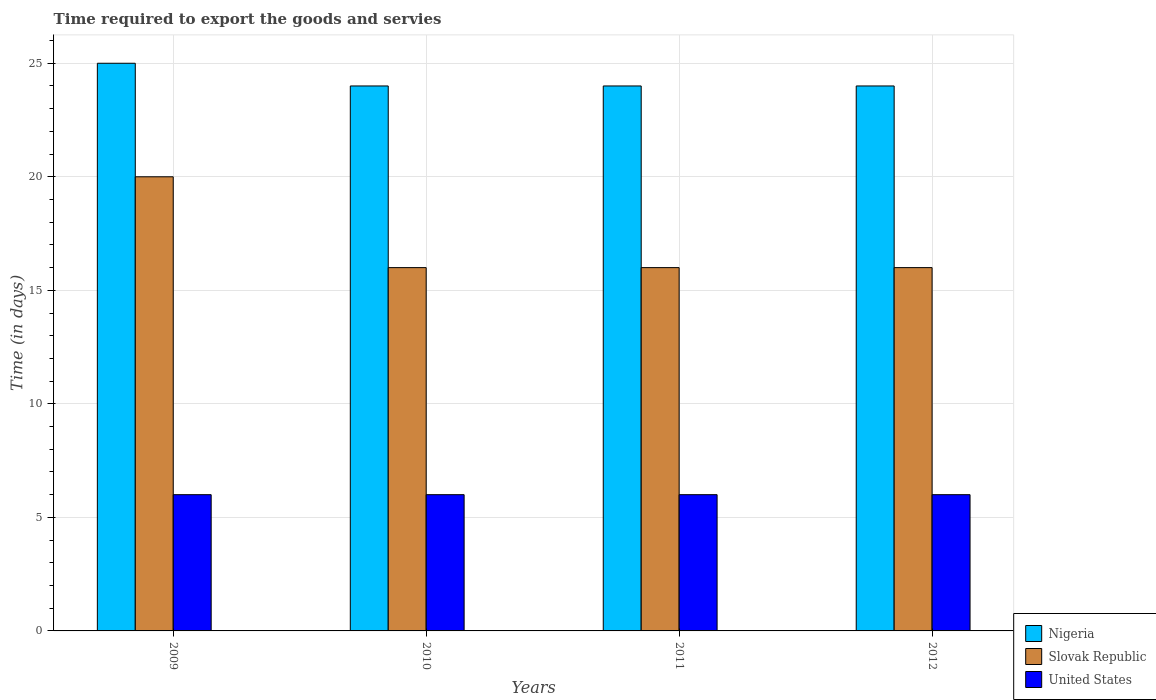How many groups of bars are there?
Your answer should be compact. 4. Are the number of bars per tick equal to the number of legend labels?
Offer a very short reply. Yes. Are the number of bars on each tick of the X-axis equal?
Keep it short and to the point. Yes. How many bars are there on the 2nd tick from the right?
Give a very brief answer. 3. What is the number of days required to export the goods and services in Slovak Republic in 2012?
Provide a short and direct response. 16. Across all years, what is the maximum number of days required to export the goods and services in Slovak Republic?
Your answer should be very brief. 20. Across all years, what is the minimum number of days required to export the goods and services in United States?
Provide a succinct answer. 6. In which year was the number of days required to export the goods and services in United States maximum?
Offer a terse response. 2009. In which year was the number of days required to export the goods and services in Nigeria minimum?
Provide a succinct answer. 2010. What is the total number of days required to export the goods and services in United States in the graph?
Your answer should be very brief. 24. What is the difference between the number of days required to export the goods and services in United States in 2009 and that in 2011?
Make the answer very short. 0. What is the difference between the number of days required to export the goods and services in Slovak Republic in 2011 and the number of days required to export the goods and services in United States in 2009?
Your answer should be very brief. 10. In the year 2010, what is the difference between the number of days required to export the goods and services in United States and number of days required to export the goods and services in Nigeria?
Give a very brief answer. -18. In how many years, is the number of days required to export the goods and services in United States greater than 12 days?
Ensure brevity in your answer.  0. What is the ratio of the number of days required to export the goods and services in United States in 2009 to that in 2010?
Offer a very short reply. 1. What is the difference between the highest and the lowest number of days required to export the goods and services in Slovak Republic?
Give a very brief answer. 4. In how many years, is the number of days required to export the goods and services in Slovak Republic greater than the average number of days required to export the goods and services in Slovak Republic taken over all years?
Your response must be concise. 1. Is the sum of the number of days required to export the goods and services in Nigeria in 2009 and 2012 greater than the maximum number of days required to export the goods and services in United States across all years?
Offer a terse response. Yes. What does the 1st bar from the left in 2009 represents?
Give a very brief answer. Nigeria. What does the 2nd bar from the right in 2011 represents?
Offer a very short reply. Slovak Republic. Is it the case that in every year, the sum of the number of days required to export the goods and services in Nigeria and number of days required to export the goods and services in Slovak Republic is greater than the number of days required to export the goods and services in United States?
Make the answer very short. Yes. Are all the bars in the graph horizontal?
Your answer should be very brief. No. What is the difference between two consecutive major ticks on the Y-axis?
Provide a short and direct response. 5. Are the values on the major ticks of Y-axis written in scientific E-notation?
Keep it short and to the point. No. Where does the legend appear in the graph?
Your answer should be compact. Bottom right. How are the legend labels stacked?
Give a very brief answer. Vertical. What is the title of the graph?
Offer a terse response. Time required to export the goods and servies. Does "Germany" appear as one of the legend labels in the graph?
Ensure brevity in your answer.  No. What is the label or title of the X-axis?
Provide a succinct answer. Years. What is the label or title of the Y-axis?
Your answer should be compact. Time (in days). What is the Time (in days) of Slovak Republic in 2009?
Offer a terse response. 20. What is the Time (in days) of United States in 2009?
Keep it short and to the point. 6. What is the Time (in days) in Nigeria in 2010?
Make the answer very short. 24. What is the Time (in days) in Nigeria in 2012?
Ensure brevity in your answer.  24. What is the Time (in days) in United States in 2012?
Your answer should be compact. 6. Across all years, what is the maximum Time (in days) in Nigeria?
Offer a very short reply. 25. Across all years, what is the maximum Time (in days) in United States?
Offer a very short reply. 6. Across all years, what is the minimum Time (in days) of Nigeria?
Make the answer very short. 24. Across all years, what is the minimum Time (in days) of Slovak Republic?
Offer a very short reply. 16. Across all years, what is the minimum Time (in days) of United States?
Your answer should be very brief. 6. What is the total Time (in days) of Nigeria in the graph?
Provide a short and direct response. 97. What is the difference between the Time (in days) of Nigeria in 2009 and that in 2010?
Offer a terse response. 1. What is the difference between the Time (in days) in Slovak Republic in 2009 and that in 2010?
Your answer should be compact. 4. What is the difference between the Time (in days) of Nigeria in 2009 and that in 2011?
Your answer should be compact. 1. What is the difference between the Time (in days) of Slovak Republic in 2009 and that in 2011?
Give a very brief answer. 4. What is the difference between the Time (in days) of United States in 2009 and that in 2011?
Keep it short and to the point. 0. What is the difference between the Time (in days) of United States in 2009 and that in 2012?
Keep it short and to the point. 0. What is the difference between the Time (in days) of Nigeria in 2010 and that in 2011?
Offer a terse response. 0. What is the difference between the Time (in days) of Slovak Republic in 2010 and that in 2011?
Make the answer very short. 0. What is the difference between the Time (in days) in Nigeria in 2010 and that in 2012?
Your answer should be very brief. 0. What is the difference between the Time (in days) in Slovak Republic in 2010 and that in 2012?
Offer a very short reply. 0. What is the difference between the Time (in days) in United States in 2010 and that in 2012?
Your response must be concise. 0. What is the difference between the Time (in days) in Nigeria in 2011 and that in 2012?
Your response must be concise. 0. What is the difference between the Time (in days) in Slovak Republic in 2011 and that in 2012?
Your response must be concise. 0. What is the difference between the Time (in days) in United States in 2011 and that in 2012?
Provide a succinct answer. 0. What is the difference between the Time (in days) of Nigeria in 2009 and the Time (in days) of Slovak Republic in 2011?
Offer a terse response. 9. What is the difference between the Time (in days) in Nigeria in 2009 and the Time (in days) in United States in 2011?
Offer a terse response. 19. What is the difference between the Time (in days) of Nigeria in 2009 and the Time (in days) of Slovak Republic in 2012?
Your answer should be compact. 9. What is the difference between the Time (in days) in Nigeria in 2010 and the Time (in days) in United States in 2011?
Provide a succinct answer. 18. What is the difference between the Time (in days) in Slovak Republic in 2010 and the Time (in days) in United States in 2011?
Your response must be concise. 10. What is the difference between the Time (in days) of Nigeria in 2010 and the Time (in days) of United States in 2012?
Offer a very short reply. 18. What is the difference between the Time (in days) in Nigeria in 2011 and the Time (in days) in Slovak Republic in 2012?
Your response must be concise. 8. What is the difference between the Time (in days) of Slovak Republic in 2011 and the Time (in days) of United States in 2012?
Ensure brevity in your answer.  10. What is the average Time (in days) of Nigeria per year?
Make the answer very short. 24.25. In the year 2009, what is the difference between the Time (in days) of Nigeria and Time (in days) of Slovak Republic?
Ensure brevity in your answer.  5. In the year 2010, what is the difference between the Time (in days) in Slovak Republic and Time (in days) in United States?
Offer a terse response. 10. In the year 2011, what is the difference between the Time (in days) of Nigeria and Time (in days) of Slovak Republic?
Make the answer very short. 8. In the year 2011, what is the difference between the Time (in days) of Nigeria and Time (in days) of United States?
Give a very brief answer. 18. What is the ratio of the Time (in days) in Nigeria in 2009 to that in 2010?
Keep it short and to the point. 1.04. What is the ratio of the Time (in days) in Slovak Republic in 2009 to that in 2010?
Provide a succinct answer. 1.25. What is the ratio of the Time (in days) in United States in 2009 to that in 2010?
Provide a short and direct response. 1. What is the ratio of the Time (in days) in Nigeria in 2009 to that in 2011?
Give a very brief answer. 1.04. What is the ratio of the Time (in days) in Nigeria in 2009 to that in 2012?
Provide a short and direct response. 1.04. What is the ratio of the Time (in days) in United States in 2009 to that in 2012?
Ensure brevity in your answer.  1. What is the ratio of the Time (in days) of Slovak Republic in 2010 to that in 2011?
Ensure brevity in your answer.  1. What is the ratio of the Time (in days) in United States in 2010 to that in 2011?
Provide a short and direct response. 1. What is the ratio of the Time (in days) in Slovak Republic in 2010 to that in 2012?
Ensure brevity in your answer.  1. What is the ratio of the Time (in days) of United States in 2011 to that in 2012?
Ensure brevity in your answer.  1. What is the difference between the highest and the lowest Time (in days) in Slovak Republic?
Provide a succinct answer. 4. 